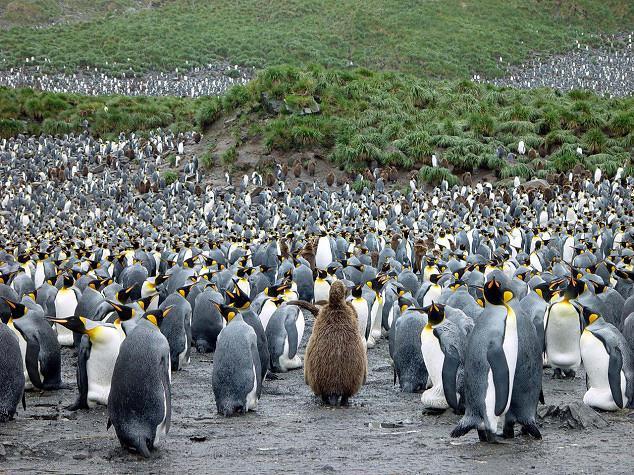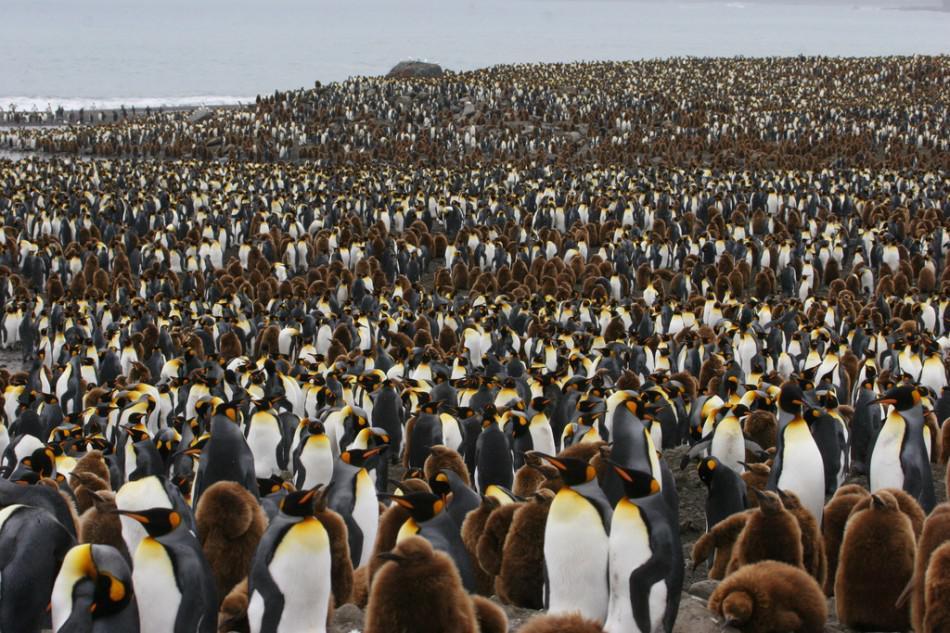The first image is the image on the left, the second image is the image on the right. Given the left and right images, does the statement "At least one of the images features a young penguin in brown downy feathers, at the foreground of the scene." hold true? Answer yes or no. Yes. 